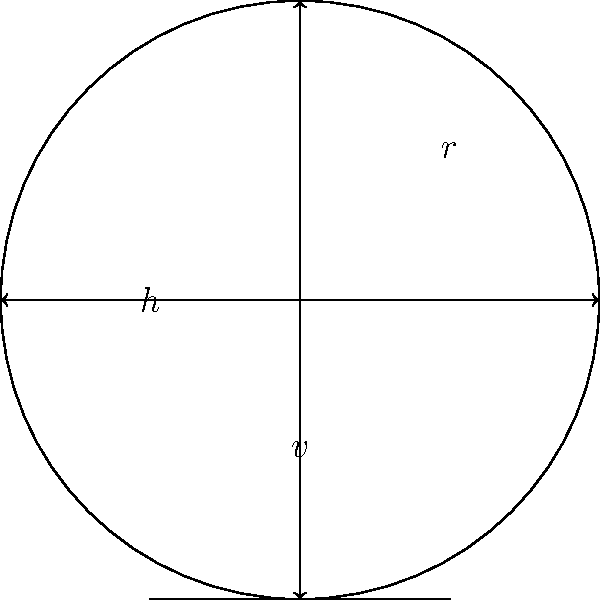Consider the symmetries of a simplified podcast microphone icon as shown in the figure. The icon consists of a circular microphone head and a rectangular stand. Which of the following groups best describes the symmetry group of this icon, and what is its order?

A) $C_2$
B) $C_4$
C) $D_2$
D) $D_4$ Let's analyze the symmetries of the podcast microphone icon step-by-step:

1) First, we identify the symmetry operations that leave the icon unchanged:
   - Rotation by 180° (r²)
   - Vertical reflection (v)
   - Horizontal reflection (h)
   - Identity operation (e)

2) These symmetry operations form a group under composition.

3) The group has four elements: {e, r², v, h}

4) This group is isomorphic to the dihedral group $D_2$, also known as the Klein four-group.

5) Properties of $D_2$:
   - It's abelian (all elements commute)
   - r² = v² = h² = e
   - r²v = h, r²h = v, vh = r²

6) The order of this group is 4.

7) Looking at the given options:
   A) $C_2$ has only 2 elements
   B) $C_4$ has 4 elements but different structure (cyclic)
   C) $D_2$ matches our analysis
   D) $D_4$ has 8 elements (too many)

Therefore, the symmetry group of the podcast microphone icon is best described by $D_2$ (option C), and its order is 4.
Answer: $D_2$, order 4 